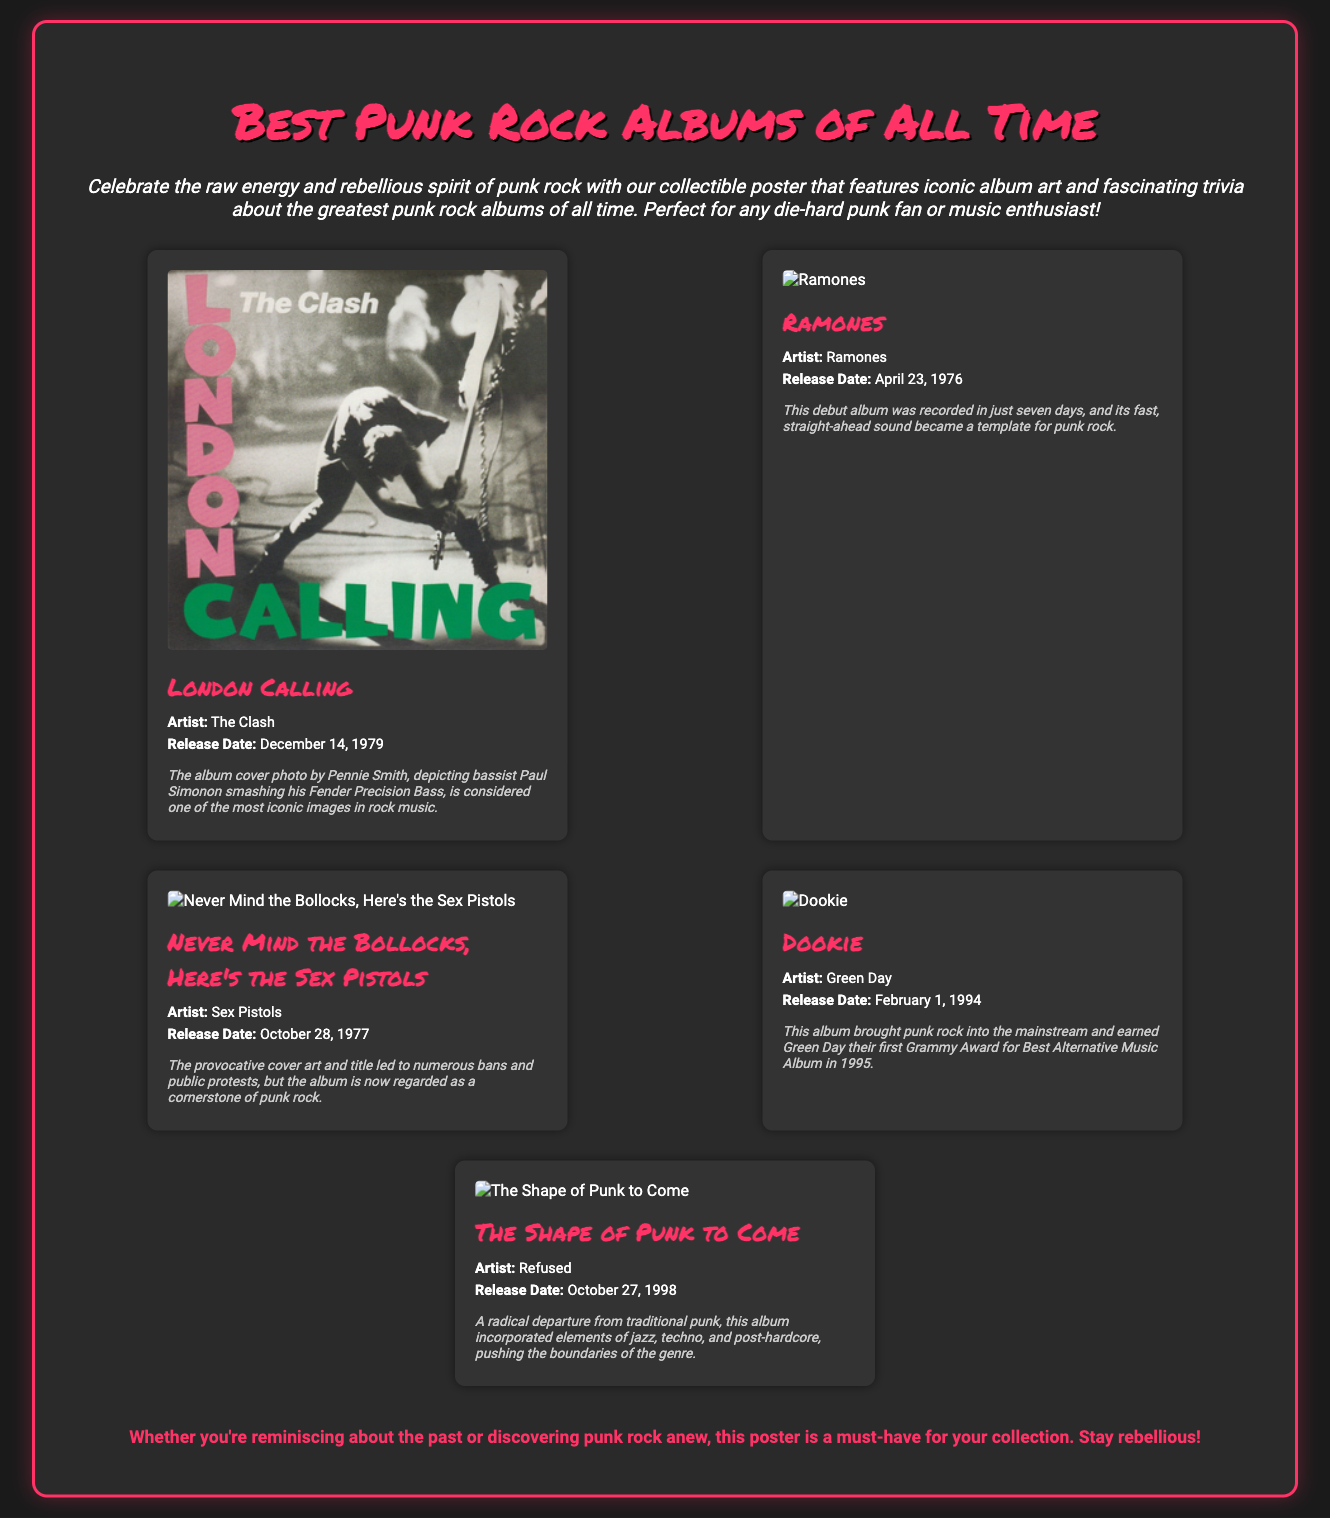What is the title of the poster? The title of the poster is prominently displayed at the top of the document.
Answer: Best Punk Rock Albums of All Time Which band's album cover features a photo of a bassist smashing their guitar? The trivia section specifically mentions the iconic image associated with this band.
Answer: The Clash What is the release date of the album "Dookie"? The document lists the release date of "Dookie" along with other album information.
Answer: February 1, 1994 How many albums are featured in the document? The document presents a collection of albums in a stylish layout, indicating a specific number.
Answer: Five Which artist released the album "Never Mind the Bollocks, Here's the Sex Pistols"? The artist's name is mentioned directly above the album title in the document.
Answer: Sex Pistols Which album is described as a "radical departure from traditional punk"? The trivia for this album mentions innovative elements that diverge from traditional punk.
Answer: The Shape of Punk to Come What color is the border of the poster? The visual design specifies the border color surrounding the poster's content.
Answer: Pink Which album is noted for bringing punk rock into the mainstream? This information is found in the trivia section of the respective album.
Answer: Dookie 